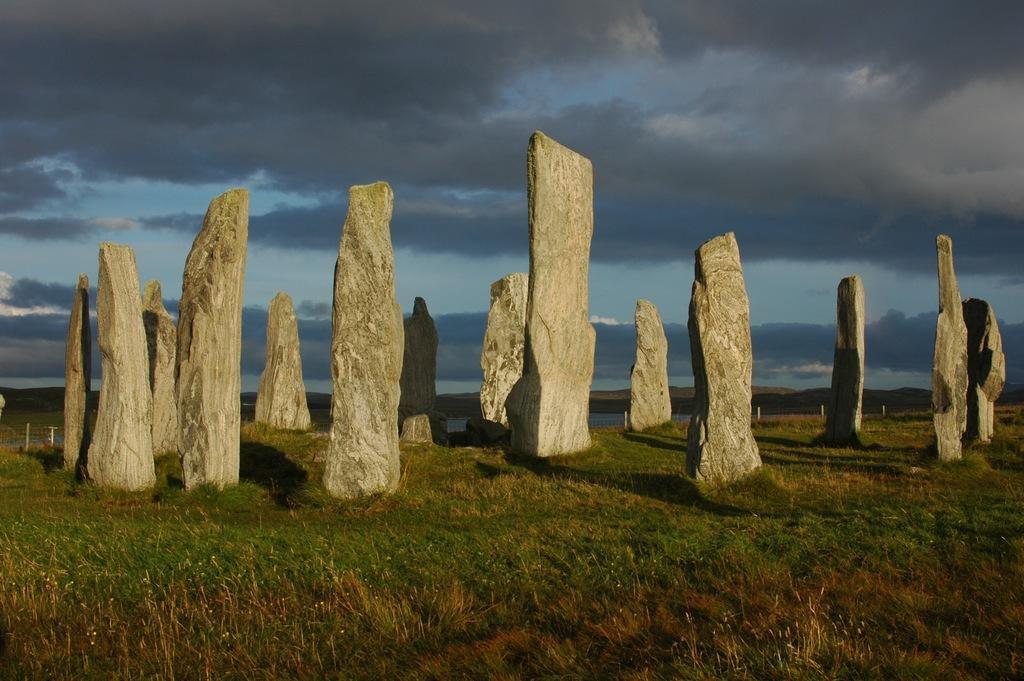In one or two sentences, can you explain what this image depicts? In this image, we can see stones on the grass. Background we can see water, poles, mountains and cloudy sky. 